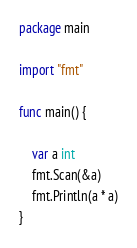Convert code to text. <code><loc_0><loc_0><loc_500><loc_500><_Go_>package main

import "fmt"

func main() {

	var a int
	fmt.Scan(&a)
	fmt.Println(a * a)
}
</code> 